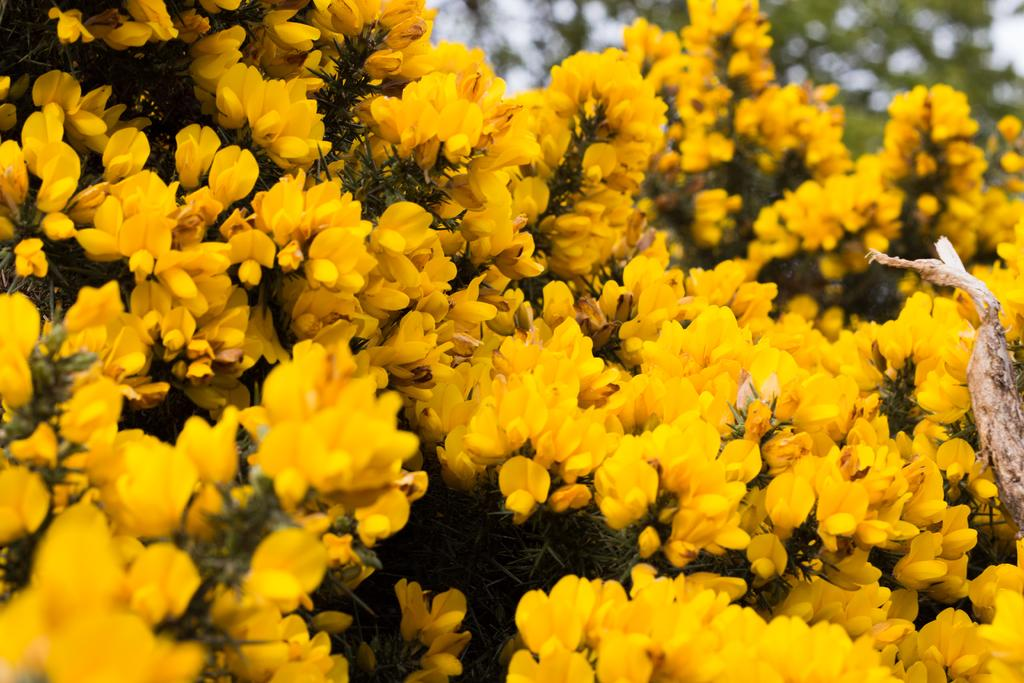What type of living organisms can be seen in the image? There are flowers and plants in the image. What parts of the flowers and plants are visible in the image? There are stems in the image. How would you describe the background of the image? The background of the image is blurred. What is the income of the person wearing the locket in the image? There is no person wearing a locket in the image, as it only features flowers and plants. 